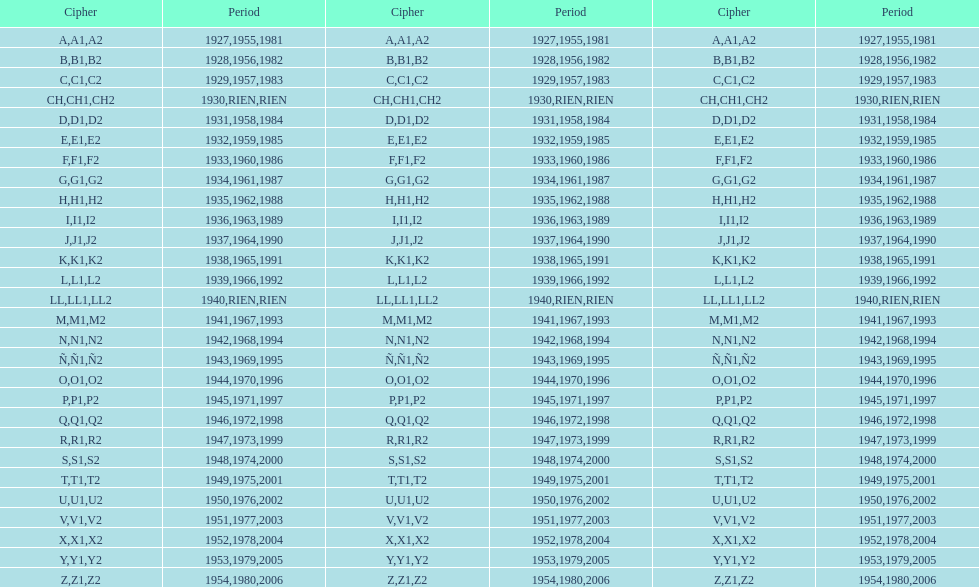In which year was the lowest stamp issued? 1927. 